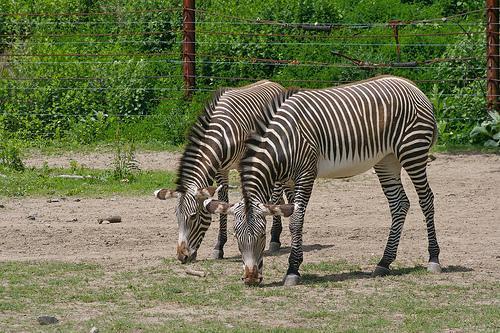How many animals are in the photo?
Give a very brief answer. 2. How many zebras are drinking water?
Give a very brief answer. 0. 